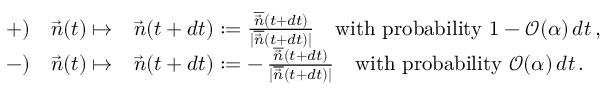<formula> <loc_0><loc_0><loc_500><loc_500>\begin{array} { r l } { { + } ) \quad \vec { n } ( t ) \mapsto } & { \vec { n } ( t + d t ) \colon = \frac { \overline { { \vec { n } } } ( t + d t ) } { | \overline { { \vec { n } } } ( t + d t ) | } \quad w i t h p r o b a b i l i t y 1 - \mathcal { O } ( \alpha ) \, d t \, , } \\ { { - } ) \quad \vec { n } ( t ) \mapsto } & { \vec { n } ( t + d t ) \colon = - \, \frac { \overline { { \vec { n } } } ( t + d t ) } { | \overline { { \vec { n } } } ( t + d t ) | } \quad w i t h p r o b a b i l i t y \mathcal { O } ( \alpha ) \, d t \, . } \end{array}</formula> 